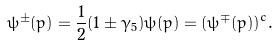Convert formula to latex. <formula><loc_0><loc_0><loc_500><loc_500>\psi ^ { \pm } ( p ) = \frac { 1 } { 2 } ( 1 \pm \gamma _ { 5 } ) \psi ( p ) = ( \psi ^ { \mp } ( p ) ) ^ { c } .</formula> 